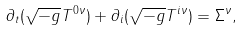<formula> <loc_0><loc_0><loc_500><loc_500>\partial _ { t } ( \sqrt { - g } T ^ { 0 \nu } ) + \partial _ { i } ( \sqrt { - g } T ^ { i \nu } ) = \Sigma ^ { \nu } ,</formula> 